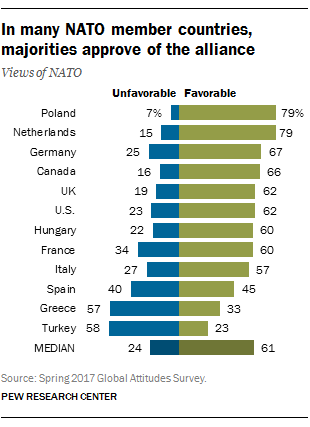Specify some key components in this picture. The favorable percentages of Hungary and France are different. According to the data, Poland had a more favorable percentage value of 79% compared to the other countries in the dataset. 